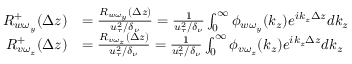<formula> <loc_0><loc_0><loc_500><loc_500>\begin{array} { r l } { R _ { w \omega _ { y } } ^ { + } ( \Delta z ) } & { = \frac { R _ { w \omega _ { y } } ( \Delta z ) } { u _ { \tau } ^ { 2 } / \delta _ { \nu } } = \frac { 1 } { u _ { \tau } ^ { 2 } / \delta _ { \nu } } \int _ { 0 } ^ { \infty } \phi _ { w \omega _ { y } } ( k _ { z } ) e ^ { i k _ { z } \Delta z } d k _ { z } } \\ { R _ { v \omega _ { z } } ^ { + } ( \Delta z ) } & { = \frac { R _ { v \omega _ { z } } ( \Delta z ) } { u _ { \tau } ^ { 2 } / \delta _ { \nu } } = \frac { 1 } { u _ { \tau } ^ { 2 } / \delta _ { \nu } } \int _ { 0 } ^ { \infty } \phi _ { v \omega _ { z } } ( k _ { z } ) e ^ { i k _ { z } \Delta z } d k _ { z } } \end{array}</formula> 